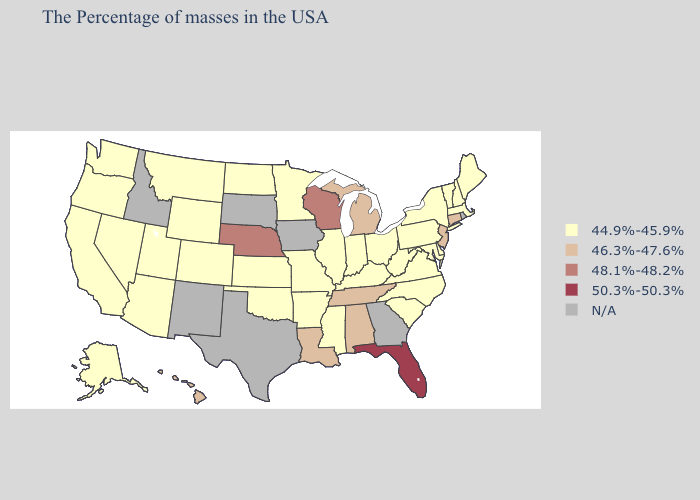Does Alabama have the lowest value in the South?
Quick response, please. No. Does Florida have the highest value in the USA?
Be succinct. Yes. What is the highest value in the MidWest ?
Write a very short answer. 48.1%-48.2%. Name the states that have a value in the range N/A?
Concise answer only. Rhode Island, Georgia, Iowa, Texas, South Dakota, New Mexico, Idaho. Does Alabama have the lowest value in the South?
Short answer required. No. Which states have the highest value in the USA?
Quick response, please. Florida. Among the states that border California , which have the highest value?
Concise answer only. Arizona, Nevada, Oregon. What is the lowest value in the USA?
Give a very brief answer. 44.9%-45.9%. Does the map have missing data?
Concise answer only. Yes. Name the states that have a value in the range 46.3%-47.6%?
Give a very brief answer. Connecticut, New Jersey, Michigan, Alabama, Tennessee, Louisiana, Hawaii. What is the value of Arkansas?
Quick response, please. 44.9%-45.9%. What is the lowest value in the USA?
Give a very brief answer. 44.9%-45.9%. What is the lowest value in the Northeast?
Short answer required. 44.9%-45.9%. Name the states that have a value in the range 44.9%-45.9%?
Keep it brief. Maine, Massachusetts, New Hampshire, Vermont, New York, Delaware, Maryland, Pennsylvania, Virginia, North Carolina, South Carolina, West Virginia, Ohio, Kentucky, Indiana, Illinois, Mississippi, Missouri, Arkansas, Minnesota, Kansas, Oklahoma, North Dakota, Wyoming, Colorado, Utah, Montana, Arizona, Nevada, California, Washington, Oregon, Alaska. Which states have the highest value in the USA?
Quick response, please. Florida. 